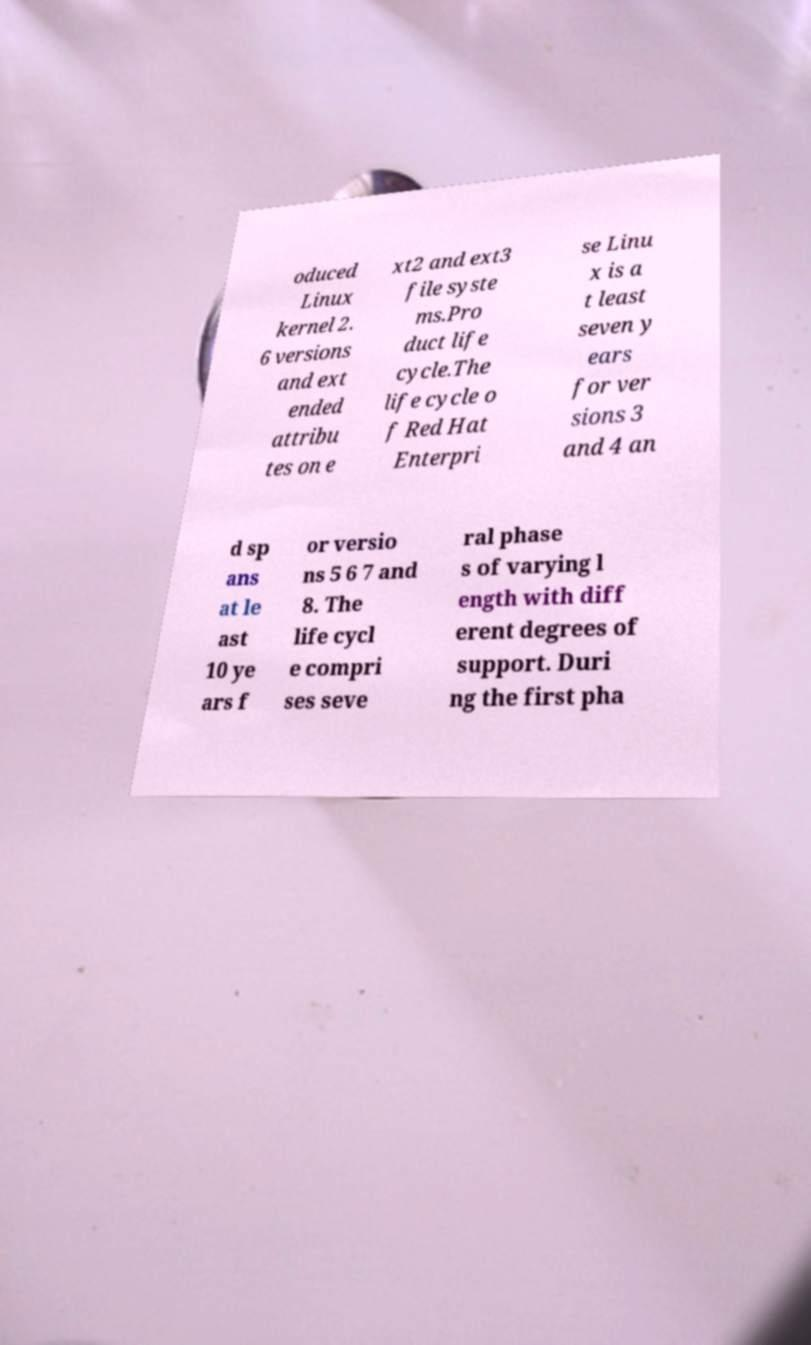Could you extract and type out the text from this image? oduced Linux kernel 2. 6 versions and ext ended attribu tes on e xt2 and ext3 file syste ms.Pro duct life cycle.The life cycle o f Red Hat Enterpri se Linu x is a t least seven y ears for ver sions 3 and 4 an d sp ans at le ast 10 ye ars f or versio ns 5 6 7 and 8. The life cycl e compri ses seve ral phase s of varying l ength with diff erent degrees of support. Duri ng the first pha 